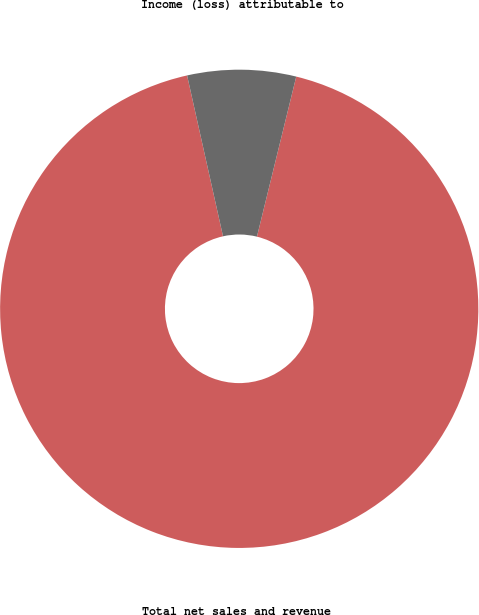Convert chart. <chart><loc_0><loc_0><loc_500><loc_500><pie_chart><fcel>Total net sales and revenue<fcel>Income (loss) attributable to<nl><fcel>92.67%<fcel>7.33%<nl></chart> 